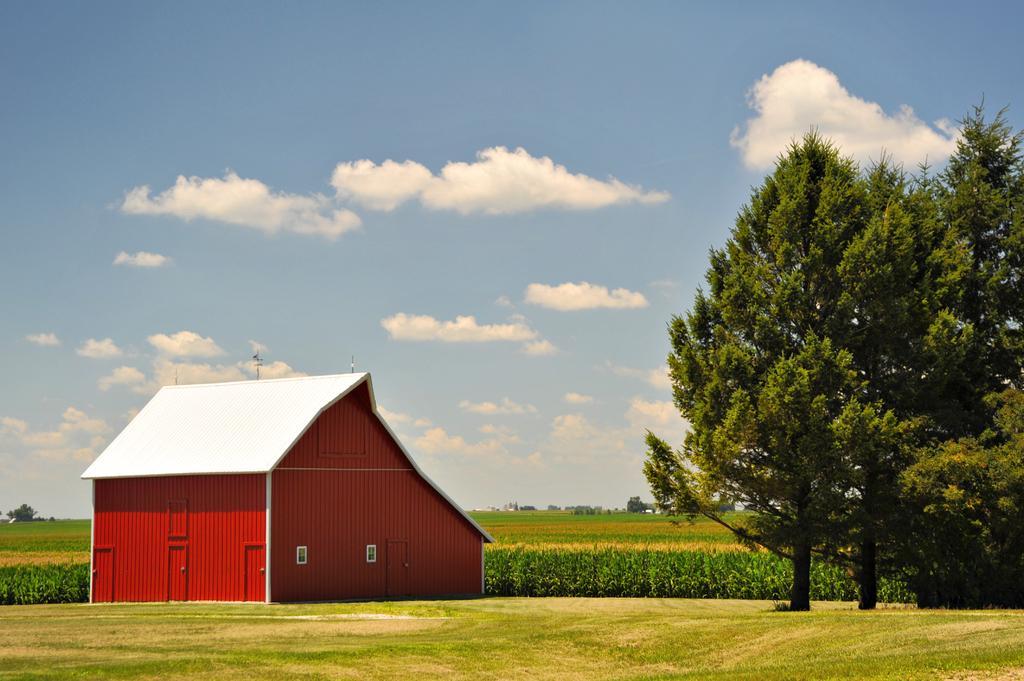In one or two sentences, can you explain what this image depicts? In this image there is the ground. There is grass on the ground. To the left there is a house. To the right there are trees. In the background there are plants. At the top there is the sky. 